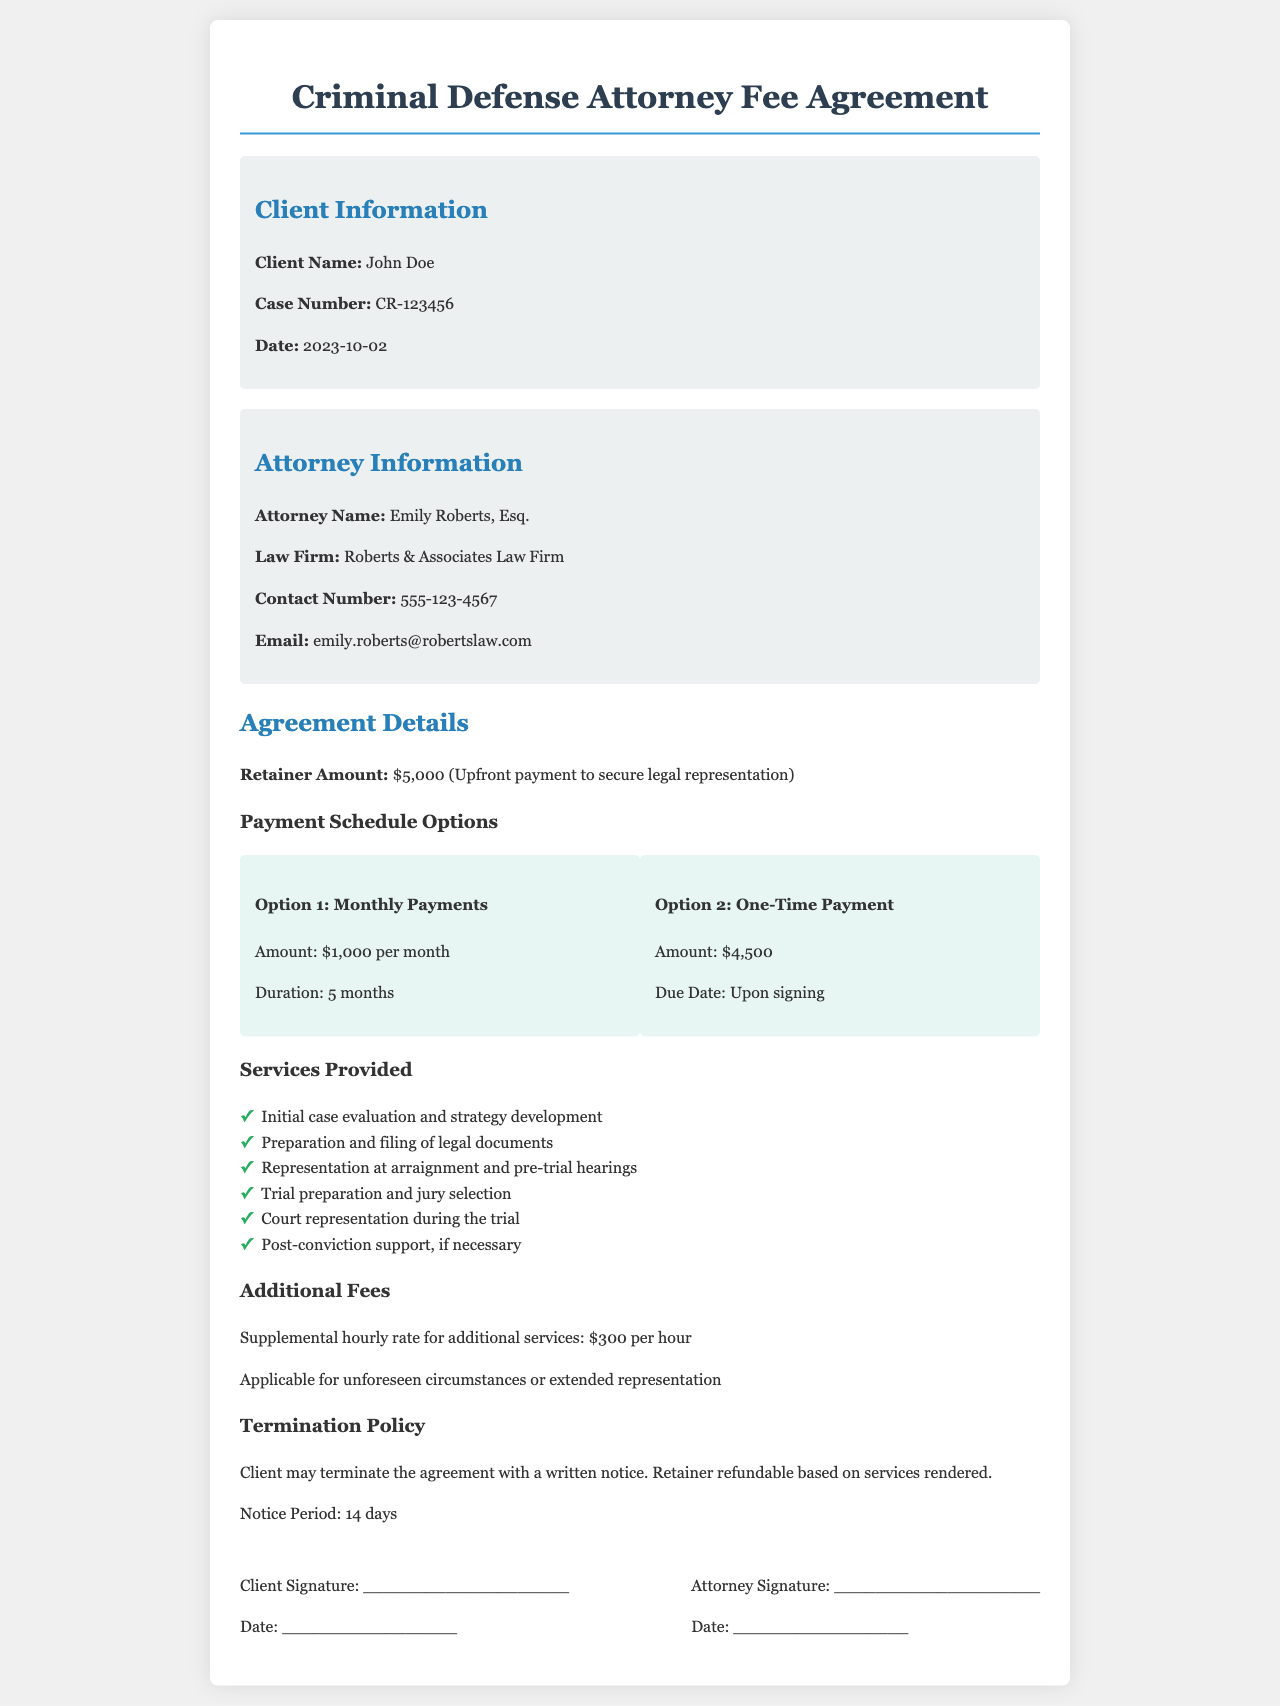what is the retainer amount? The retainer amount is specified in the document as the upfront payment for legal representation, which is $5,000.
Answer: $5,000 who is the attorney? The document explicitly names the attorney responsible for the case as Emily Roberts, Esq.
Answer: Emily Roberts, Esq what is the additional hourly rate for services? The document outlines a supplemental hourly rate for any additional services which is $300 per hour.
Answer: $300 per hour how long is the monthly payment option? The payment schedule details specify that the monthly payment option lasts for a duration of 5 months.
Answer: 5 months what is the due date for the one-time payment option? The document states that the one-time payment amount is due upon signing.
Answer: Upon signing what is necessary to terminate the agreement? The termination policy outlines that a written notice is necessary to terminate the agreement.
Answer: Written notice which law firm is representing the client? The document provides the name of the law firm representing the client as Roberts & Associates Law Firm.
Answer: Roberts & Associates Law Firm what services are provided during the trial? The document lists court representation during the trial as a service provided to the client.
Answer: Court representation during the trial what is the notice period for termination? The document specifies that the notice period for termination of the agreement is 14 days.
Answer: 14 days 